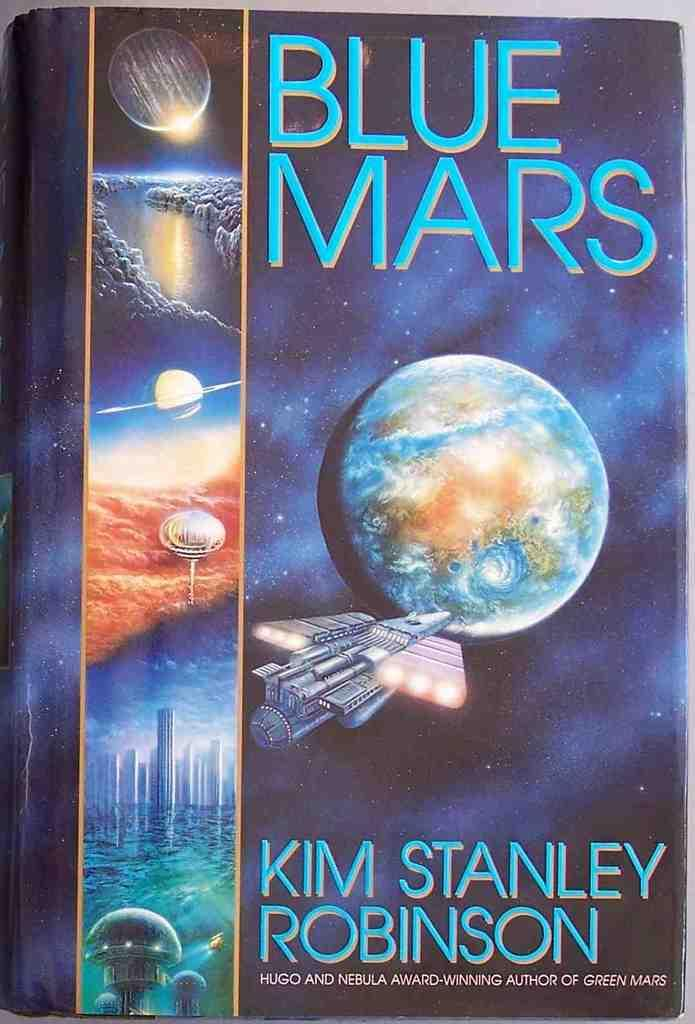<image>
Give a short and clear explanation of the subsequent image. A blue book cover with and image of a planet on it. 